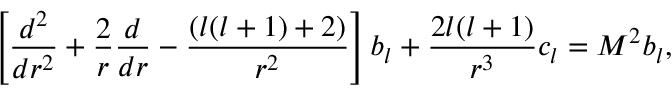Convert formula to latex. <formula><loc_0><loc_0><loc_500><loc_500>\left [ { \frac { d ^ { 2 } } { d r ^ { 2 } } } + { \frac { 2 } { r } } { \frac { d } { d r } } - { \frac { ( l ( l + 1 ) + 2 ) } { r ^ { 2 } } } \right ] b _ { l } + { \frac { 2 l ( l + 1 ) } { r ^ { 3 } } } c _ { l } = M ^ { 2 } b _ { l } ,</formula> 